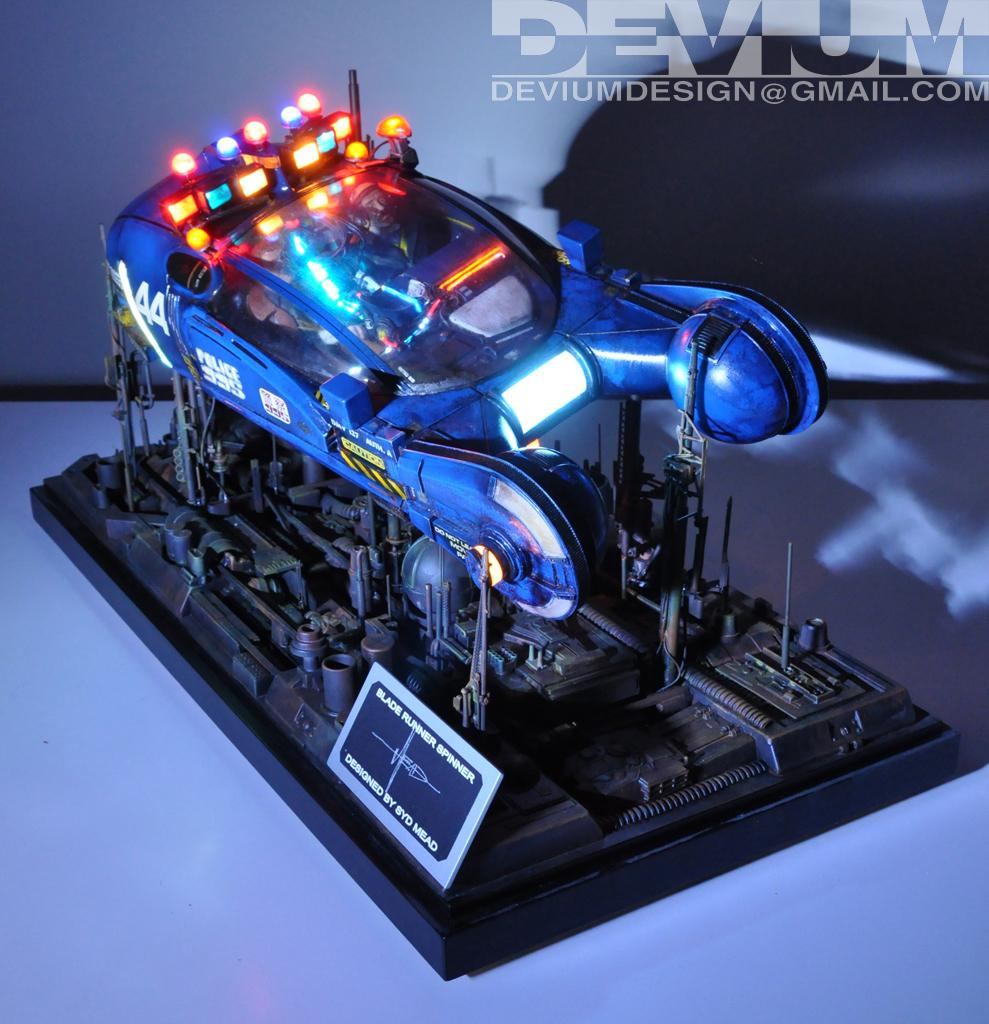What is the main object in the image? There is an object with lighting in the image. What is the color of the surface the object is placed on? The object is placed on a white surface. Where is the text located in the image? The text is in the top right corner of the image. What type of game is being played on the white surface in the image? There is no game being played in the image; it features an object with lighting placed on a white surface. How is the corn used in the image? There is no corn present in the image. 